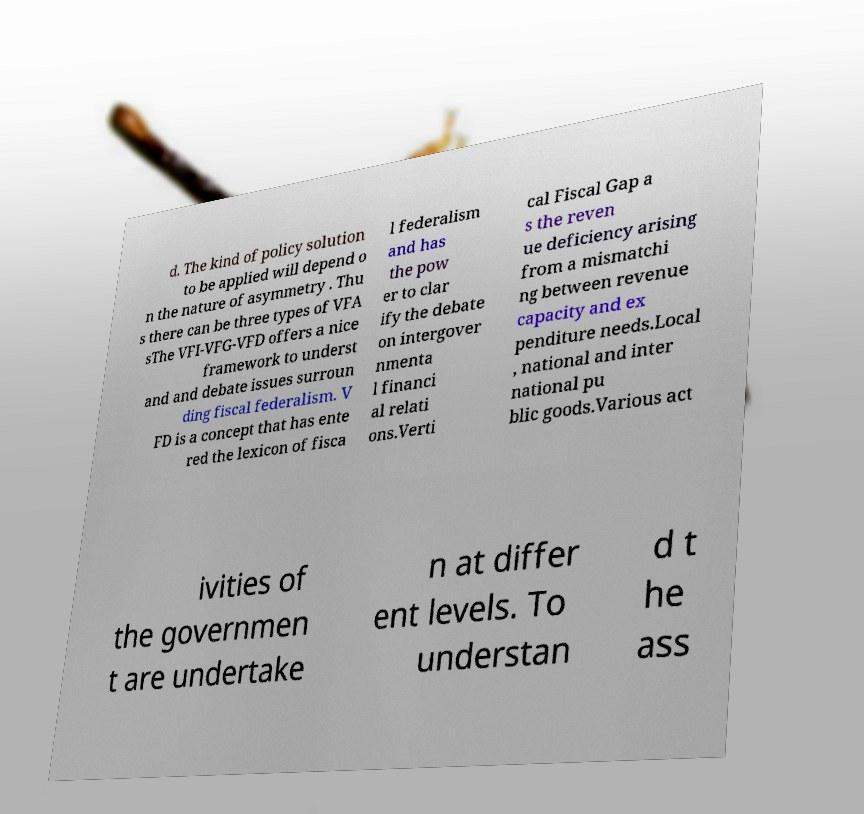What messages or text are displayed in this image? I need them in a readable, typed format. d. The kind of policy solution to be applied will depend o n the nature of asymmetry . Thu s there can be three types of VFA sThe VFI-VFG-VFD offers a nice framework to underst and and debate issues surroun ding fiscal federalism. V FD is a concept that has ente red the lexicon of fisca l federalism and has the pow er to clar ify the debate on intergover nmenta l financi al relati ons.Verti cal Fiscal Gap a s the reven ue deficiency arising from a mismatchi ng between revenue capacity and ex penditure needs.Local , national and inter national pu blic goods.Various act ivities of the governmen t are undertake n at differ ent levels. To understan d t he ass 